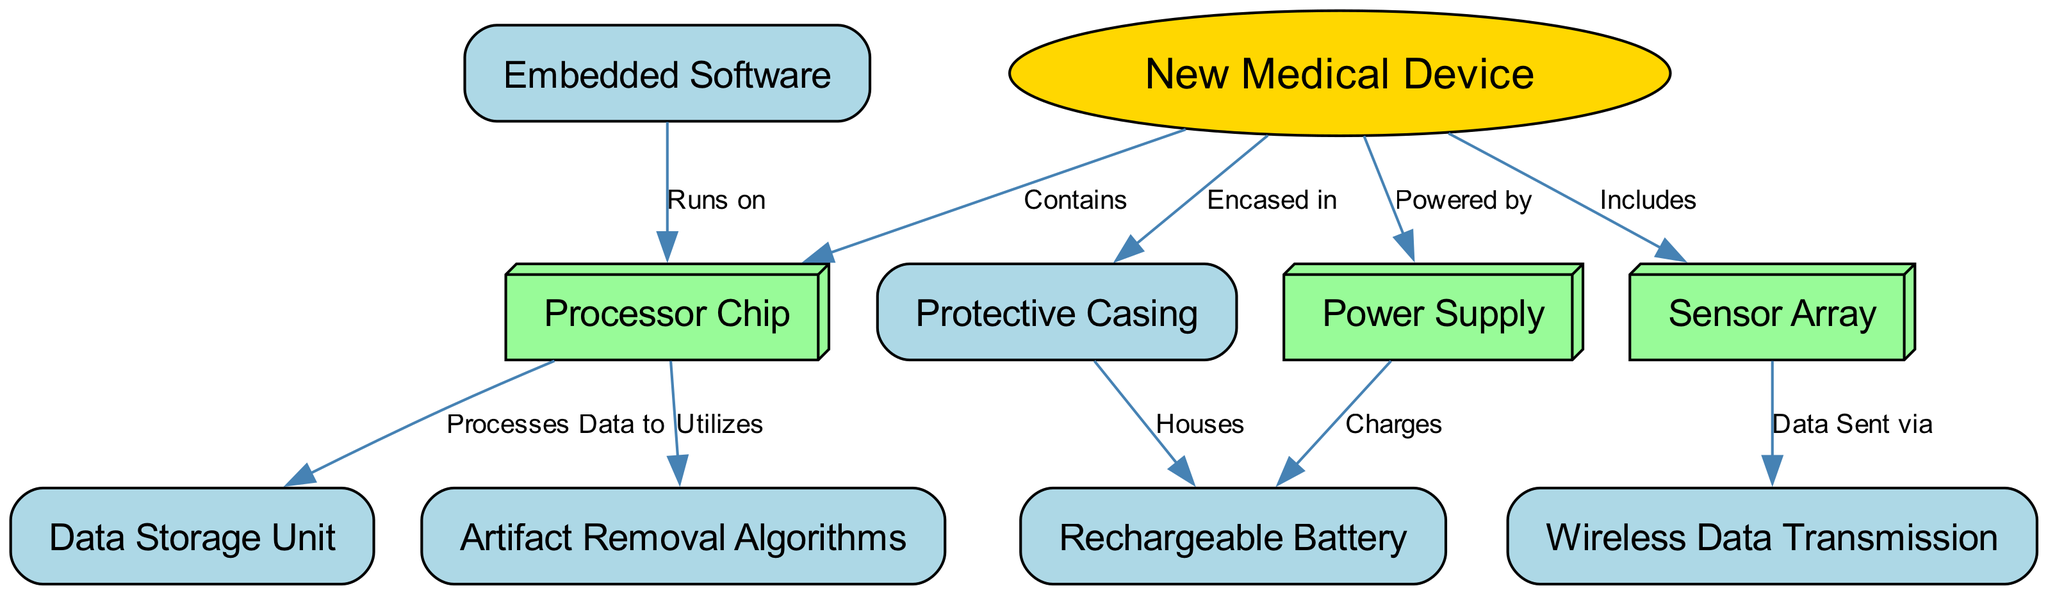What is the main component of the medical device? The main component is represented by the node labeled "New Medical Device." This is derived from the diagram, where "device" is the primary node that connects to all other components as a central element.
Answer: New Medical Device How many nodes are present in the diagram? The nodes include: New Medical Device, Sensor Array, Processor Chip, Power Supply, Protective Casing, Embedded Software, Wireless Data Transmission, Artifact Removal Algorithms, Data Storage Unit, and Rechargeable Battery. Counting these gives a total of ten nodes in the diagram.
Answer: 10 Which component is responsible for data transmission? The node labeled "Wireless Data Transmission" is connected to "Sensor Array," indicating that it carries out the function of transmitting data wirelessly. This connection confirms its role as the data transmission unit.
Answer: Wireless Data Transmission What does the Processor Chip utilize for cleaning data? The relationship between "Processor Chip" and "Artifact Removal Algorithms" indicates that the chip utilizes these algorithms for the purpose of cleaning or processing the data it receives. This link shows the function of the chip in data handling.
Answer: Artifact Removal Algorithms What is the function of the Power Supply? The "Power Supply" is connected to the "Rechargeable Battery" with the label "Charges," suggesting that its primary function is to charge this battery, thus powering the entire device. This flow indicates the energy management aspect of the device.
Answer: Charges Which component runs on Embedded Software? The connection between "Embedded Software" and "Processor Chip" shows that the software runs on this chip. This indicates that the processor chip is the platform where the software operates and performs its functions.
Answer: Processor Chip How is the Protective Casing related to the Rechargeable Battery? The relationship is defined by the connection where the "Protective Casing" is labeled as "Houses" for the "Rechargeable Battery." This shows that the casing physically contains or protects the battery.
Answer: Houses What type of data processing does the Processor Chip perform? The "Processor Chip" is connected to the "Data Storage Unit" with the label "Processes Data to," indicating that it performs data processing to store information in the data storage unit. This connection illustrates the processing flow in the device.
Answer: Processes Data to What type of algorithms does the Processor Chip utilize? The link between the "Processor Chip" and "Artifact Removal Algorithms" specifies that the chip utilizes these particular algorithms, denoting the processing capabilities of the chip regarding data management.
Answer: Artifact Removal Algorithms 